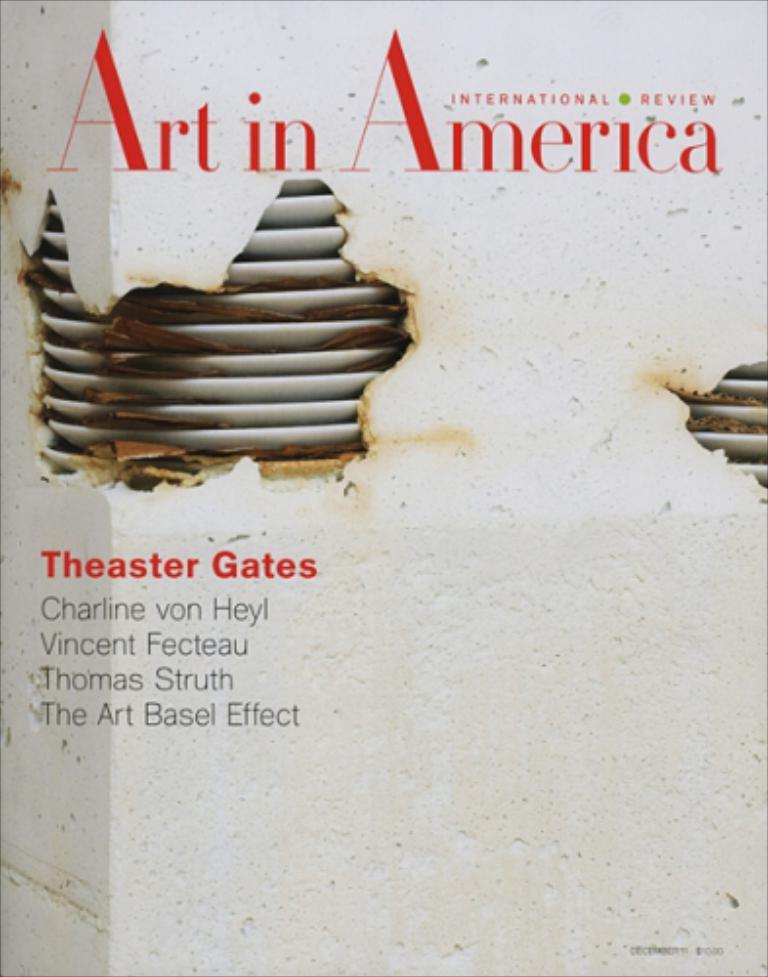<image>
Describe the image concisely. A white and red print magazine called Art in America 